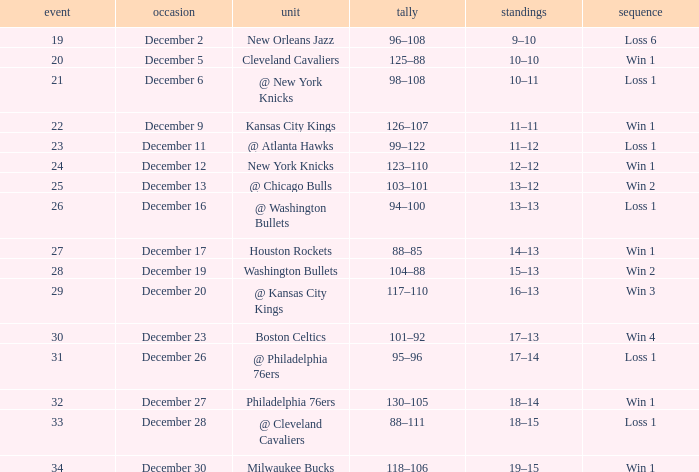What is the Score of the Game with a Record of 13–12? 103–101. 